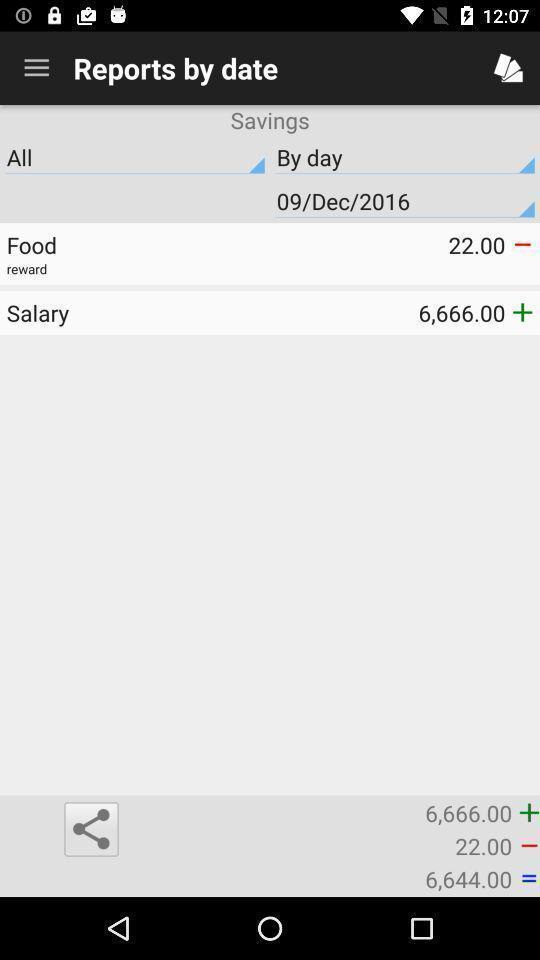Please provide a description for this image. Page showing reports by date on an app. 